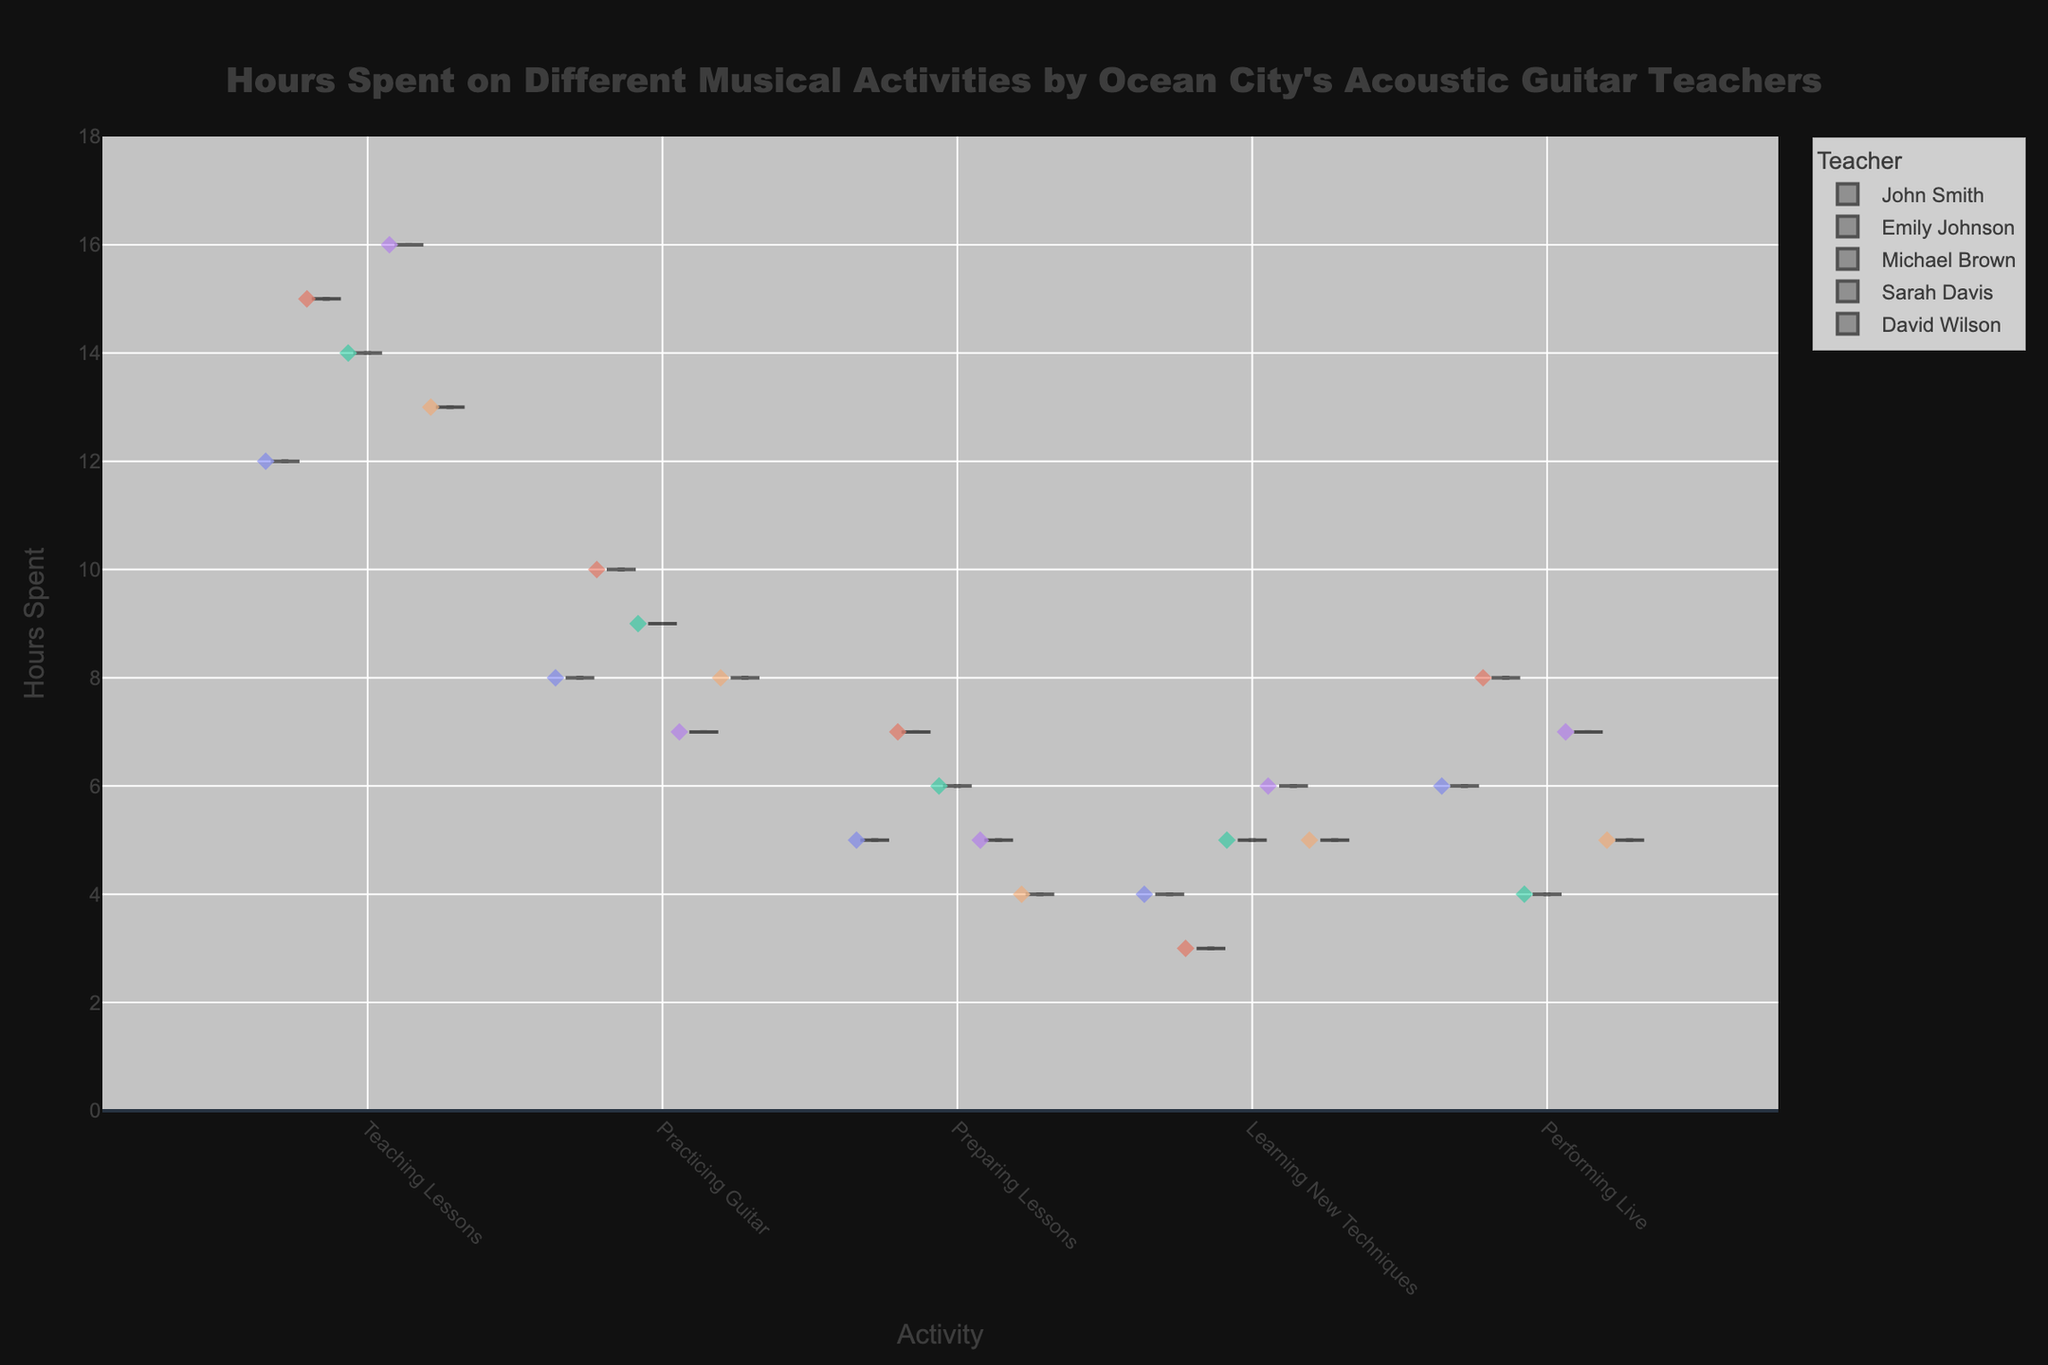What's the title of the chart? The title is usually located at the top of the chart. From the code provided, the title mentioned is "Hours Spent on Different Musical Activities by Ocean City's Acoustic Guitar Teachers".
Answer: Hours Spent on Different Musical Activities by Ocean City's Acoustic Guitar Teachers How many different musical activities are represented in the chart? The x-axis of the chart represents different musical activities. From the data, the activities are "Teaching Lessons", "Practicing Guitar", "Preparing Lessons", "Learning New Techniques", and "Performing Live". Count these distinct activities.
Answer: 5 Which teacher spends the most hours on teaching lessons? From the y-axis, look for the bar associated with "Teaching Lessons" and find the teacher with the highest value. Checking the data, Sarah Davis spends the most hours, 16 hours.
Answer: Sarah Davis What's the average number of hours spent on practicing guitar? To find the average, sum the hours spent on practicing guitar by all teachers and divide by the number of teachers. (8 + 10 + 9 + 7 + 8) / 5 = 8.4
Answer: 8.4 Which activity has the least variability in hours spent among teachers? Variability in a violin chart is visually represented by the width; narrower indicates less variability. According to the data and visual inspection of the largest violin plot widths, "Learning New Techniques" shows the least variability.
Answer: Learning New Techniques How does the number of hours spent on performing live compare between Michael Brown and Emily Johnson? Look at the y-axis values for performing live for both teachers. Emily Johnson spends 8 hours, while Michael Brown spends 4 hours. Subtracting Michael's hours from Emily gives the comparison (8 - 4).
Answer: 4 hours more What is the median number of hours spent on preparing lessons across all teachers? The violin plot usually shows a box plot for each activity. The median is the middle value of the ordered dataset. From the dataset, preparing lessons hours are 5, 7, 6, 5, 4. The median of this dataset is the third value.
Answer: 5 Is there any teacher who spends exactly the same amount of hours on two different activities? For each teacher, compare the hours spent on different activities to spot any matching values. From the dataset, John Smith spends 5 hours on both Teaching Lessons and Preparing Lessons.
Answer: Yes, John Smith Which teacher spends the least hours on learning new techniques? Find the minimum value in the "Learning New Techniques" category and identify the corresponding teacher. The lowest is 3 hours by Emily Johnson.
Answer: Emily Johnson 